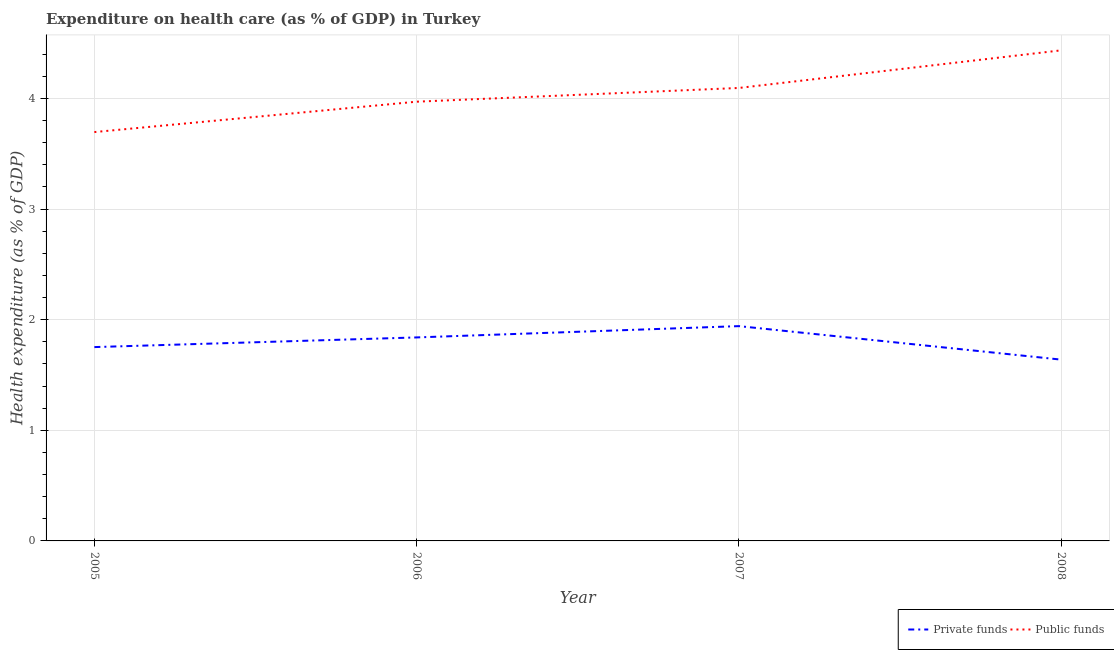How many different coloured lines are there?
Your answer should be compact. 2. Does the line corresponding to amount of public funds spent in healthcare intersect with the line corresponding to amount of private funds spent in healthcare?
Offer a terse response. No. What is the amount of private funds spent in healthcare in 2007?
Give a very brief answer. 1.94. Across all years, what is the maximum amount of private funds spent in healthcare?
Keep it short and to the point. 1.94. Across all years, what is the minimum amount of private funds spent in healthcare?
Provide a short and direct response. 1.64. In which year was the amount of public funds spent in healthcare minimum?
Provide a short and direct response. 2005. What is the total amount of private funds spent in healthcare in the graph?
Give a very brief answer. 7.17. What is the difference between the amount of private funds spent in healthcare in 2005 and that in 2006?
Your answer should be very brief. -0.09. What is the difference between the amount of private funds spent in healthcare in 2007 and the amount of public funds spent in healthcare in 2006?
Ensure brevity in your answer.  -2.03. What is the average amount of public funds spent in healthcare per year?
Keep it short and to the point. 4.05. In the year 2008, what is the difference between the amount of private funds spent in healthcare and amount of public funds spent in healthcare?
Ensure brevity in your answer.  -2.8. What is the ratio of the amount of public funds spent in healthcare in 2005 to that in 2008?
Offer a very short reply. 0.83. Is the amount of public funds spent in healthcare in 2005 less than that in 2007?
Offer a very short reply. Yes. What is the difference between the highest and the second highest amount of public funds spent in healthcare?
Offer a very short reply. 0.34. What is the difference between the highest and the lowest amount of private funds spent in healthcare?
Your answer should be very brief. 0.3. In how many years, is the amount of public funds spent in healthcare greater than the average amount of public funds spent in healthcare taken over all years?
Your answer should be very brief. 2. Is the sum of the amount of public funds spent in healthcare in 2006 and 2007 greater than the maximum amount of private funds spent in healthcare across all years?
Make the answer very short. Yes. Is the amount of public funds spent in healthcare strictly greater than the amount of private funds spent in healthcare over the years?
Give a very brief answer. Yes. How many lines are there?
Provide a succinct answer. 2. What is the difference between two consecutive major ticks on the Y-axis?
Your response must be concise. 1. Does the graph contain any zero values?
Provide a succinct answer. No. Where does the legend appear in the graph?
Provide a short and direct response. Bottom right. How many legend labels are there?
Make the answer very short. 2. What is the title of the graph?
Make the answer very short. Expenditure on health care (as % of GDP) in Turkey. Does "Quality of trade" appear as one of the legend labels in the graph?
Your response must be concise. No. What is the label or title of the Y-axis?
Provide a succinct answer. Health expenditure (as % of GDP). What is the Health expenditure (as % of GDP) in Private funds in 2005?
Ensure brevity in your answer.  1.75. What is the Health expenditure (as % of GDP) in Public funds in 2005?
Offer a terse response. 3.7. What is the Health expenditure (as % of GDP) in Private funds in 2006?
Provide a succinct answer. 1.84. What is the Health expenditure (as % of GDP) in Public funds in 2006?
Offer a terse response. 3.97. What is the Health expenditure (as % of GDP) in Private funds in 2007?
Your answer should be very brief. 1.94. What is the Health expenditure (as % of GDP) in Public funds in 2007?
Your answer should be compact. 4.1. What is the Health expenditure (as % of GDP) in Private funds in 2008?
Keep it short and to the point. 1.64. What is the Health expenditure (as % of GDP) in Public funds in 2008?
Provide a succinct answer. 4.44. Across all years, what is the maximum Health expenditure (as % of GDP) of Private funds?
Your response must be concise. 1.94. Across all years, what is the maximum Health expenditure (as % of GDP) in Public funds?
Your answer should be compact. 4.44. Across all years, what is the minimum Health expenditure (as % of GDP) in Private funds?
Give a very brief answer. 1.64. Across all years, what is the minimum Health expenditure (as % of GDP) in Public funds?
Make the answer very short. 3.7. What is the total Health expenditure (as % of GDP) in Private funds in the graph?
Provide a succinct answer. 7.17. What is the total Health expenditure (as % of GDP) of Public funds in the graph?
Your answer should be compact. 16.2. What is the difference between the Health expenditure (as % of GDP) of Private funds in 2005 and that in 2006?
Offer a terse response. -0.09. What is the difference between the Health expenditure (as % of GDP) in Public funds in 2005 and that in 2006?
Your answer should be very brief. -0.27. What is the difference between the Health expenditure (as % of GDP) in Private funds in 2005 and that in 2007?
Keep it short and to the point. -0.19. What is the difference between the Health expenditure (as % of GDP) of Public funds in 2005 and that in 2007?
Your answer should be very brief. -0.4. What is the difference between the Health expenditure (as % of GDP) in Private funds in 2005 and that in 2008?
Your answer should be compact. 0.11. What is the difference between the Health expenditure (as % of GDP) of Public funds in 2005 and that in 2008?
Offer a terse response. -0.74. What is the difference between the Health expenditure (as % of GDP) of Private funds in 2006 and that in 2007?
Make the answer very short. -0.1. What is the difference between the Health expenditure (as % of GDP) of Public funds in 2006 and that in 2007?
Make the answer very short. -0.12. What is the difference between the Health expenditure (as % of GDP) of Private funds in 2006 and that in 2008?
Ensure brevity in your answer.  0.2. What is the difference between the Health expenditure (as % of GDP) of Public funds in 2006 and that in 2008?
Offer a very short reply. -0.46. What is the difference between the Health expenditure (as % of GDP) in Private funds in 2007 and that in 2008?
Your answer should be very brief. 0.3. What is the difference between the Health expenditure (as % of GDP) of Public funds in 2007 and that in 2008?
Offer a terse response. -0.34. What is the difference between the Health expenditure (as % of GDP) in Private funds in 2005 and the Health expenditure (as % of GDP) in Public funds in 2006?
Offer a very short reply. -2.22. What is the difference between the Health expenditure (as % of GDP) in Private funds in 2005 and the Health expenditure (as % of GDP) in Public funds in 2007?
Ensure brevity in your answer.  -2.34. What is the difference between the Health expenditure (as % of GDP) in Private funds in 2005 and the Health expenditure (as % of GDP) in Public funds in 2008?
Offer a terse response. -2.68. What is the difference between the Health expenditure (as % of GDP) in Private funds in 2006 and the Health expenditure (as % of GDP) in Public funds in 2007?
Your answer should be compact. -2.26. What is the difference between the Health expenditure (as % of GDP) of Private funds in 2006 and the Health expenditure (as % of GDP) of Public funds in 2008?
Ensure brevity in your answer.  -2.6. What is the difference between the Health expenditure (as % of GDP) of Private funds in 2007 and the Health expenditure (as % of GDP) of Public funds in 2008?
Ensure brevity in your answer.  -2.49. What is the average Health expenditure (as % of GDP) in Private funds per year?
Your response must be concise. 1.79. What is the average Health expenditure (as % of GDP) of Public funds per year?
Your response must be concise. 4.05. In the year 2005, what is the difference between the Health expenditure (as % of GDP) in Private funds and Health expenditure (as % of GDP) in Public funds?
Ensure brevity in your answer.  -1.94. In the year 2006, what is the difference between the Health expenditure (as % of GDP) in Private funds and Health expenditure (as % of GDP) in Public funds?
Provide a short and direct response. -2.13. In the year 2007, what is the difference between the Health expenditure (as % of GDP) in Private funds and Health expenditure (as % of GDP) in Public funds?
Keep it short and to the point. -2.15. In the year 2008, what is the difference between the Health expenditure (as % of GDP) in Private funds and Health expenditure (as % of GDP) in Public funds?
Your answer should be compact. -2.8. What is the ratio of the Health expenditure (as % of GDP) of Private funds in 2005 to that in 2006?
Offer a terse response. 0.95. What is the ratio of the Health expenditure (as % of GDP) in Public funds in 2005 to that in 2006?
Provide a short and direct response. 0.93. What is the ratio of the Health expenditure (as % of GDP) of Private funds in 2005 to that in 2007?
Your answer should be compact. 0.9. What is the ratio of the Health expenditure (as % of GDP) in Public funds in 2005 to that in 2007?
Offer a terse response. 0.9. What is the ratio of the Health expenditure (as % of GDP) in Private funds in 2005 to that in 2008?
Your response must be concise. 1.07. What is the ratio of the Health expenditure (as % of GDP) in Public funds in 2005 to that in 2008?
Offer a very short reply. 0.83. What is the ratio of the Health expenditure (as % of GDP) of Private funds in 2006 to that in 2007?
Provide a succinct answer. 0.95. What is the ratio of the Health expenditure (as % of GDP) of Public funds in 2006 to that in 2007?
Make the answer very short. 0.97. What is the ratio of the Health expenditure (as % of GDP) in Private funds in 2006 to that in 2008?
Your answer should be very brief. 1.12. What is the ratio of the Health expenditure (as % of GDP) in Public funds in 2006 to that in 2008?
Keep it short and to the point. 0.9. What is the ratio of the Health expenditure (as % of GDP) of Private funds in 2007 to that in 2008?
Your answer should be compact. 1.18. What is the ratio of the Health expenditure (as % of GDP) in Public funds in 2007 to that in 2008?
Provide a succinct answer. 0.92. What is the difference between the highest and the second highest Health expenditure (as % of GDP) in Private funds?
Provide a succinct answer. 0.1. What is the difference between the highest and the second highest Health expenditure (as % of GDP) of Public funds?
Your response must be concise. 0.34. What is the difference between the highest and the lowest Health expenditure (as % of GDP) of Private funds?
Offer a terse response. 0.3. What is the difference between the highest and the lowest Health expenditure (as % of GDP) in Public funds?
Offer a terse response. 0.74. 